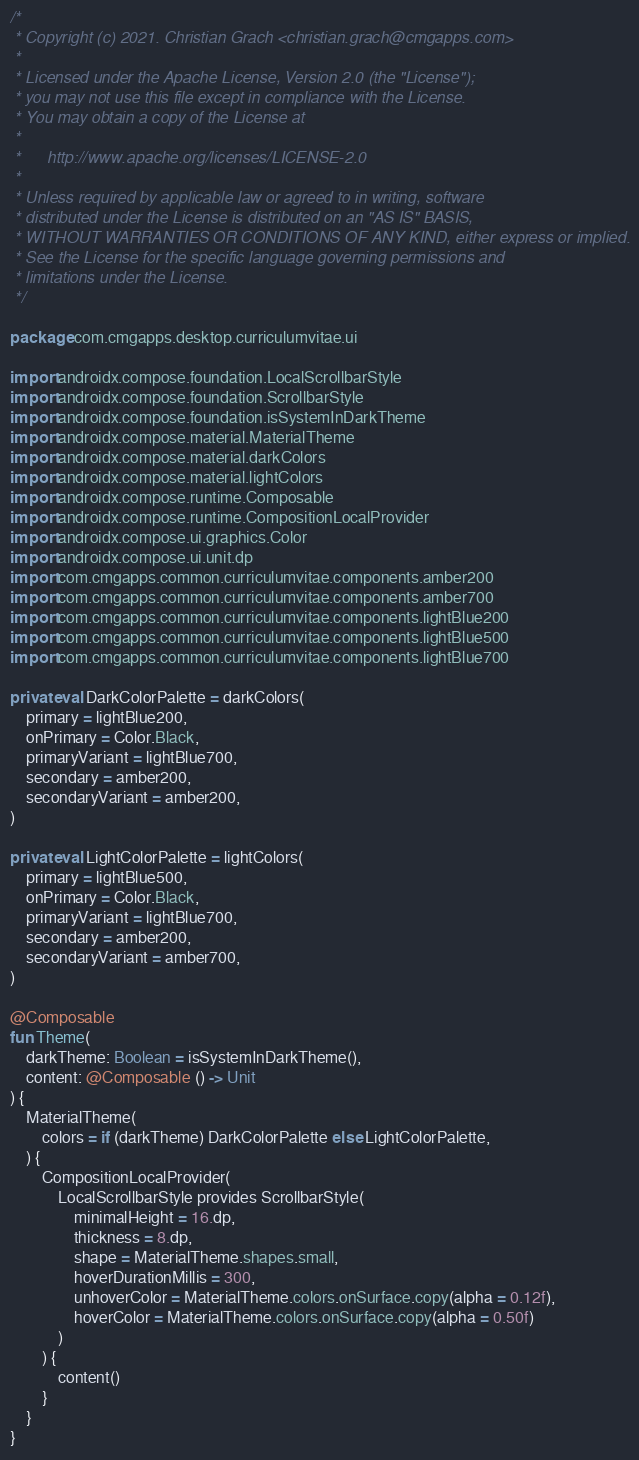Convert code to text. <code><loc_0><loc_0><loc_500><loc_500><_Kotlin_>/*
 * Copyright (c) 2021. Christian Grach <christian.grach@cmgapps.com>
 *
 * Licensed under the Apache License, Version 2.0 (the "License");
 * you may not use this file except in compliance with the License.
 * You may obtain a copy of the License at
 *
 *      http://www.apache.org/licenses/LICENSE-2.0
 *
 * Unless required by applicable law or agreed to in writing, software
 * distributed under the License is distributed on an "AS IS" BASIS,
 * WITHOUT WARRANTIES OR CONDITIONS OF ANY KIND, either express or implied.
 * See the License for the specific language governing permissions and
 * limitations under the License.
 */

package com.cmgapps.desktop.curriculumvitae.ui

import androidx.compose.foundation.LocalScrollbarStyle
import androidx.compose.foundation.ScrollbarStyle
import androidx.compose.foundation.isSystemInDarkTheme
import androidx.compose.material.MaterialTheme
import androidx.compose.material.darkColors
import androidx.compose.material.lightColors
import androidx.compose.runtime.Composable
import androidx.compose.runtime.CompositionLocalProvider
import androidx.compose.ui.graphics.Color
import androidx.compose.ui.unit.dp
import com.cmgapps.common.curriculumvitae.components.amber200
import com.cmgapps.common.curriculumvitae.components.amber700
import com.cmgapps.common.curriculumvitae.components.lightBlue200
import com.cmgapps.common.curriculumvitae.components.lightBlue500
import com.cmgapps.common.curriculumvitae.components.lightBlue700

private val DarkColorPalette = darkColors(
    primary = lightBlue200,
    onPrimary = Color.Black,
    primaryVariant = lightBlue700,
    secondary = amber200,
    secondaryVariant = amber200,
)

private val LightColorPalette = lightColors(
    primary = lightBlue500,
    onPrimary = Color.Black,
    primaryVariant = lightBlue700,
    secondary = amber200,
    secondaryVariant = amber700,
)

@Composable
fun Theme(
    darkTheme: Boolean = isSystemInDarkTheme(),
    content: @Composable () -> Unit
) {
    MaterialTheme(
        colors = if (darkTheme) DarkColorPalette else LightColorPalette,
    ) {
        CompositionLocalProvider(
            LocalScrollbarStyle provides ScrollbarStyle(
                minimalHeight = 16.dp,
                thickness = 8.dp,
                shape = MaterialTheme.shapes.small,
                hoverDurationMillis = 300,
                unhoverColor = MaterialTheme.colors.onSurface.copy(alpha = 0.12f),
                hoverColor = MaterialTheme.colors.onSurface.copy(alpha = 0.50f)
            )
        ) {
            content()
        }
    }
}
</code> 